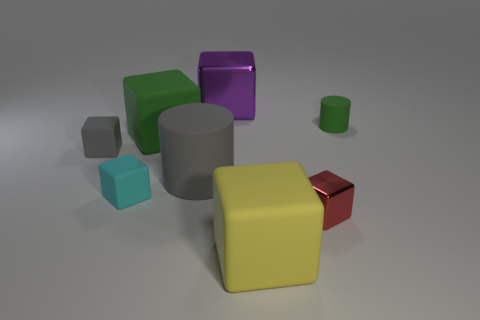Subtract all yellow blocks. How many blocks are left? 5 Add 1 cyan matte cylinders. How many objects exist? 9 Subtract all green cylinders. How many cylinders are left? 1 Add 5 tiny gray rubber blocks. How many tiny gray rubber blocks exist? 6 Subtract 0 cyan spheres. How many objects are left? 8 Subtract all blocks. How many objects are left? 2 Subtract 6 blocks. How many blocks are left? 0 Subtract all red blocks. Subtract all brown balls. How many blocks are left? 5 Subtract all green cylinders. How many cyan cubes are left? 1 Subtract all small yellow metallic objects. Subtract all small cubes. How many objects are left? 5 